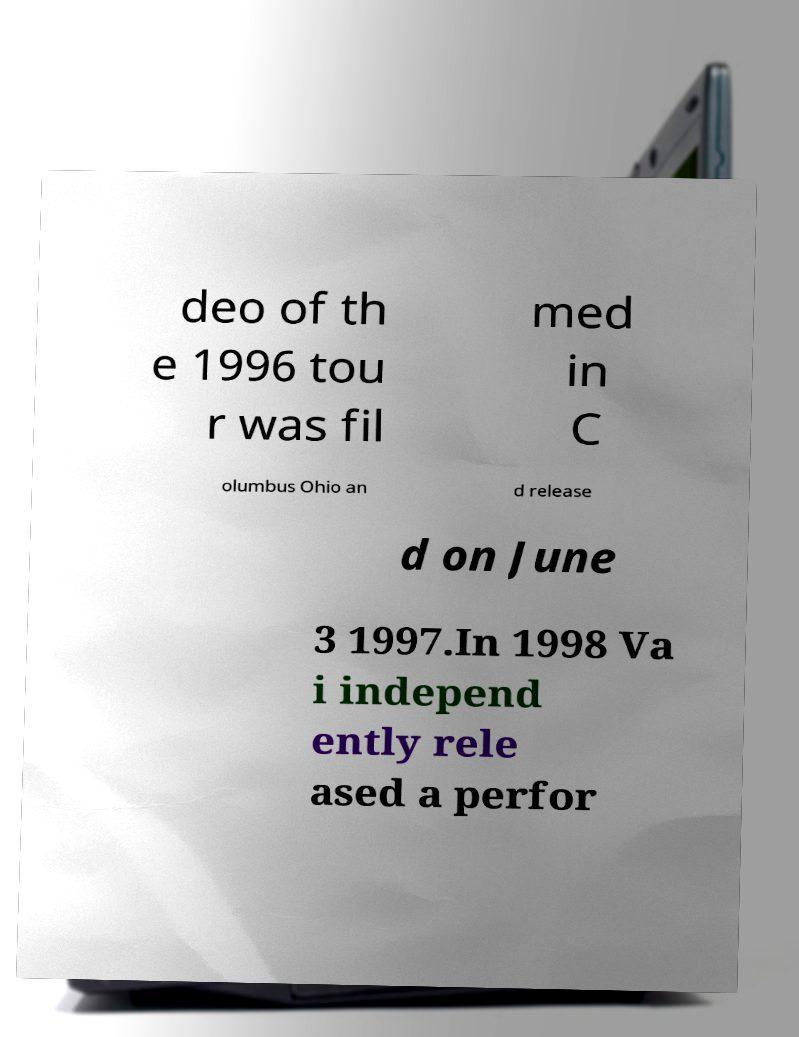Could you assist in decoding the text presented in this image and type it out clearly? deo of th e 1996 tou r was fil med in C olumbus Ohio an d release d on June 3 1997.In 1998 Va i independ ently rele ased a perfor 